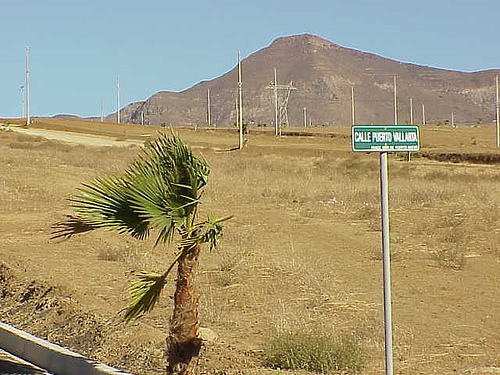Read and extract the text from this image. CALLE 